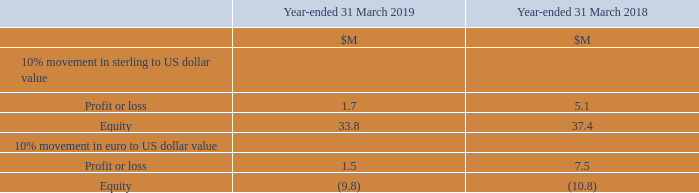Foreign Currency Risk
The Group is exposed to translation and transaction foreign exchange risk. Several other currencies in addition to the reporting currency of US dollar are used, including sterling and the euro. The Group experiences currency exchange differences arising upon retranslation of monetary items (primarily short-term inter-Company balances and long-term borrowings), which are recognised as an expense in the period the difference occurs. The Group endeavours to match cash inflows and outflows in the various currencies; the Group typically invoices its customers in their local currency and pays its local expenses in local currency, as a means to mitigate this risk.
The Group is also exposed to exchange differences arising from the translation of its subsidiaries’ Financial Statements into the Group’s reporting currency of US dollar, with the corresponding exchange differences taken directly to equity.
The following table illustrates the movement that ten per cent in the value of sterling or the euro against the US dollar would have had on the Group’s profit or loss for the period and on the Group’s equity as at the end of the period.
Any foreign exchange variance would be recognised as unrealised foreign exchange in the Consolidated Statement of Profit or Loss and have no impact on cash flows.
Where does the currency exchange differences that the Group experiences arise from? Arising upon retranslation of monetary items (primarily short-term inter-company balances and long-term borrowings), which are recognised as an expense in the period the difference occurs. How would any foreign exchange variance be recognised? As unrealised foreign exchange in the consolidated statement of profit or loss and have no impact on cash flows. For which currencies does the table record the effect of a 10% movement against the US dollar? Sterling, euro. In which year was the impact on Equity from a 10% movement in sterling to US dollar value larger? 37.4>33.8
Answer: 2018. What was the change in the impact on Equity from a 10% movement in sterling to US dollar value in 2019 from 2018?
Answer scale should be: million. 33.8-37.4
Answer: -3.6. What was the percentage change in the impact on Equity from a 10% movement in sterling to US dollar value in 2019 from 2018?
Answer scale should be: percent. (33.8-37.4)/37.4
Answer: -9.63. 